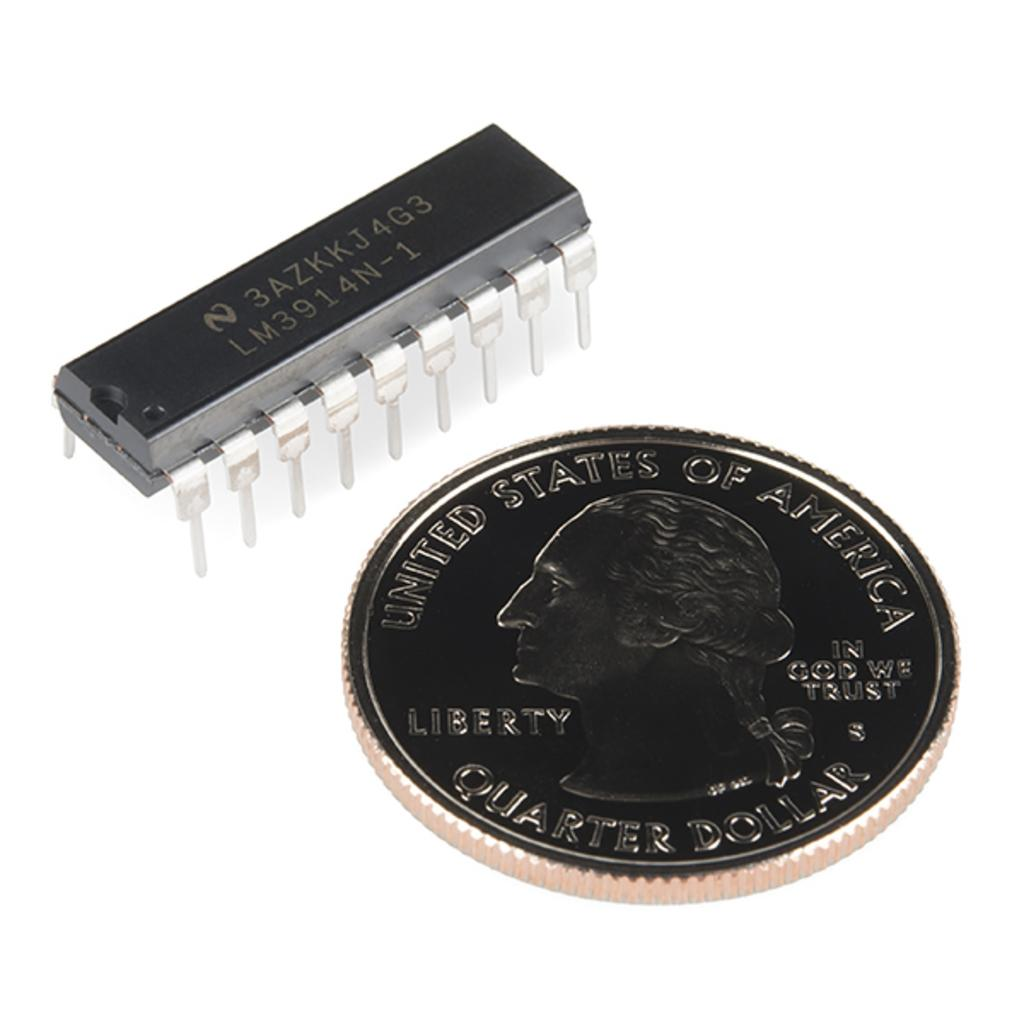<image>
Relay a brief, clear account of the picture shown. A quarter is on the table with an item that has the code 3AZKKJ4G3 on it 